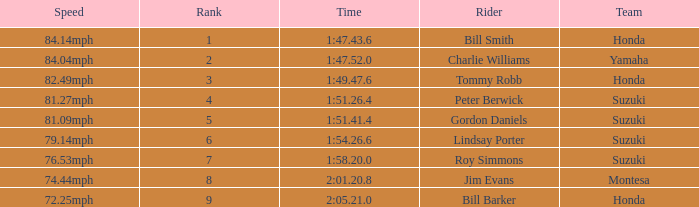Which rider had a time of 1:54.26.6? Lindsay Porter. 